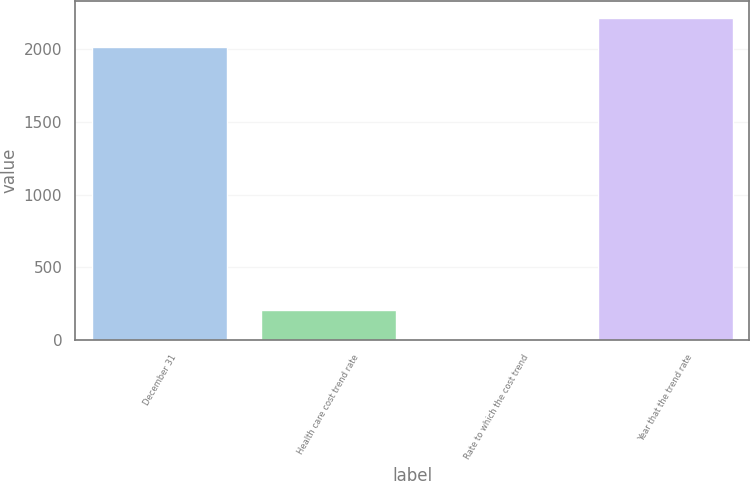Convert chart to OTSL. <chart><loc_0><loc_0><loc_500><loc_500><bar_chart><fcel>December 31<fcel>Health care cost trend rate<fcel>Rate to which the cost trend<fcel>Year that the trend rate<nl><fcel>2017<fcel>207.25<fcel>4.5<fcel>2219.75<nl></chart> 